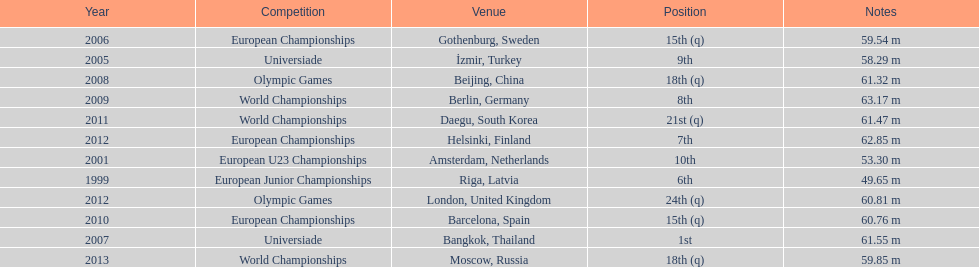Which year held the most competitions? 2012. 